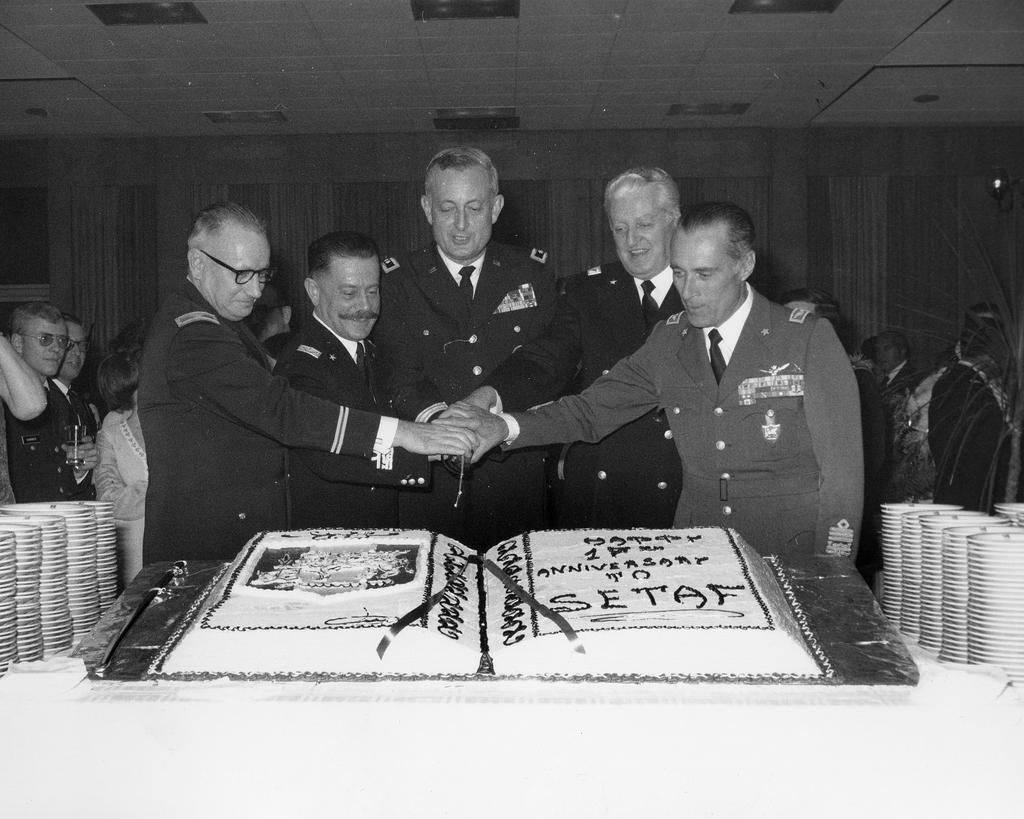Could you give a brief overview of what you see in this image? In the image we can see black and white picture of people standing, wearing clothes and some of them are wearing spectacles and they are smiling. Here we can see the cake and the background is slightly dark. 